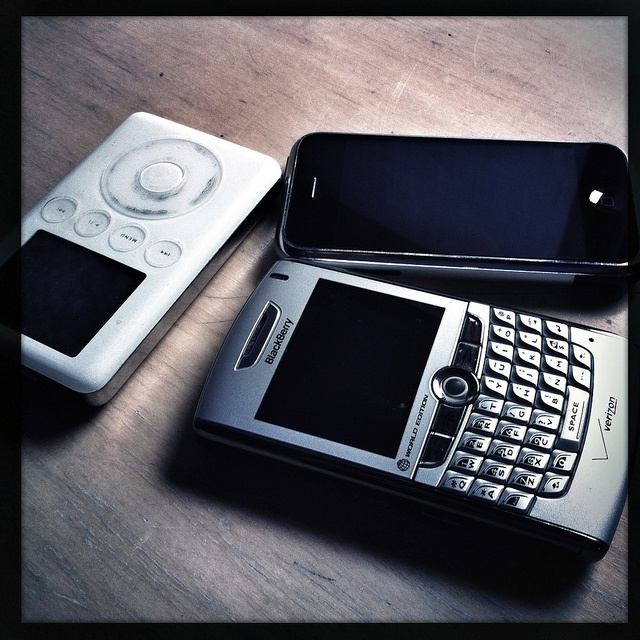Describe the objects in this image and their specific colors. I can see cell phone in black, white, darkgray, and gray tones, cell phone in black, lightgray, gray, and darkgray tones, and cell phone in black, gray, and white tones in this image. 